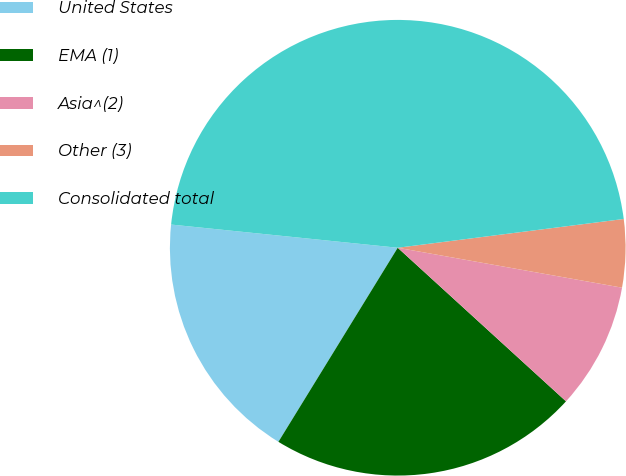Convert chart. <chart><loc_0><loc_0><loc_500><loc_500><pie_chart><fcel>United States<fcel>EMA (1)<fcel>Asia^(2)<fcel>Other (3)<fcel>Consolidated total<nl><fcel>17.85%<fcel>22.0%<fcel>8.97%<fcel>4.82%<fcel>46.36%<nl></chart> 